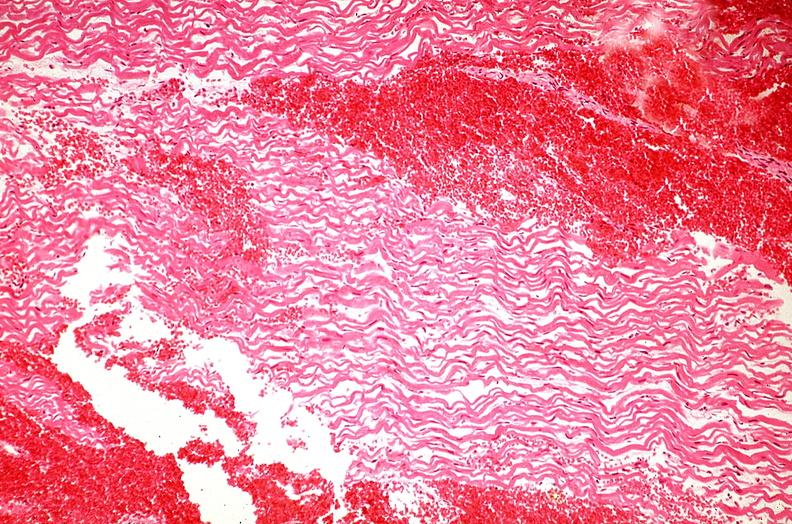what does this image show?
Answer the question using a single word or phrase. Heart 